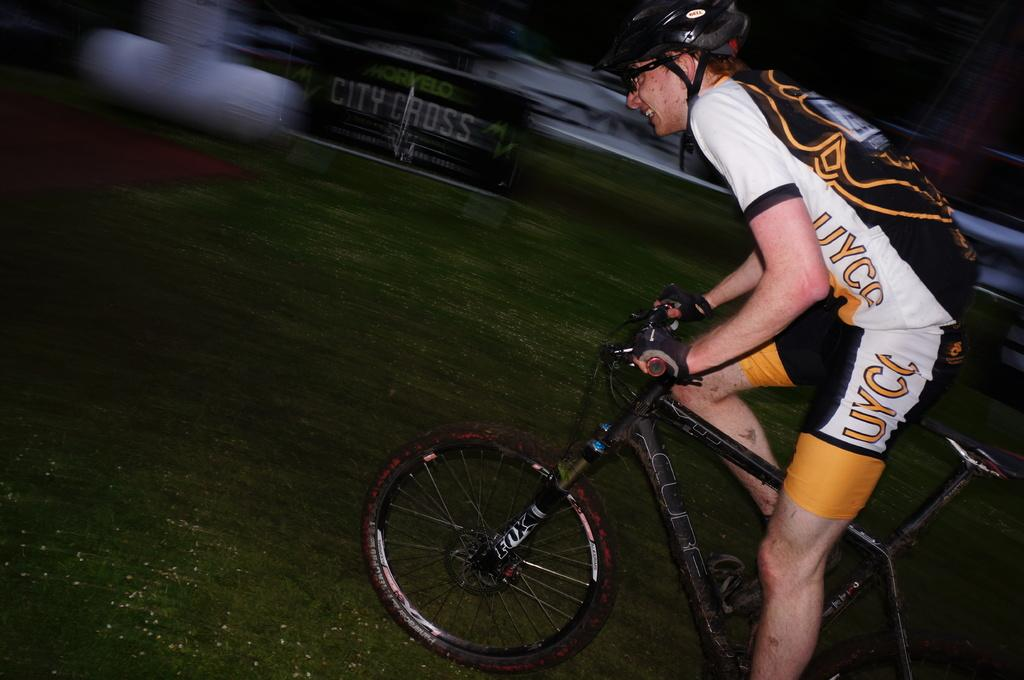What is the man in the image doing? The man is riding a bicycle in the image. What is the man wearing on his head? The man is wearing a helmet in the image. What is the condition of the bicycle in the image? The bicycle is on the ground in the image. What can be seen on the board with text in the image? The specific text on the board is not mentioned, but it is present in the image. What is the color of the banner in the image? The color of the banner is white in the image. What type of surface is the bicycle on? The bicycle is on grass in the image. Where is the sister playing on the playground in the image? There is no mention of a sister or a playground in the image. Can you see any icicles hanging from the bicycle in the image? There are no icicles present in the image. 